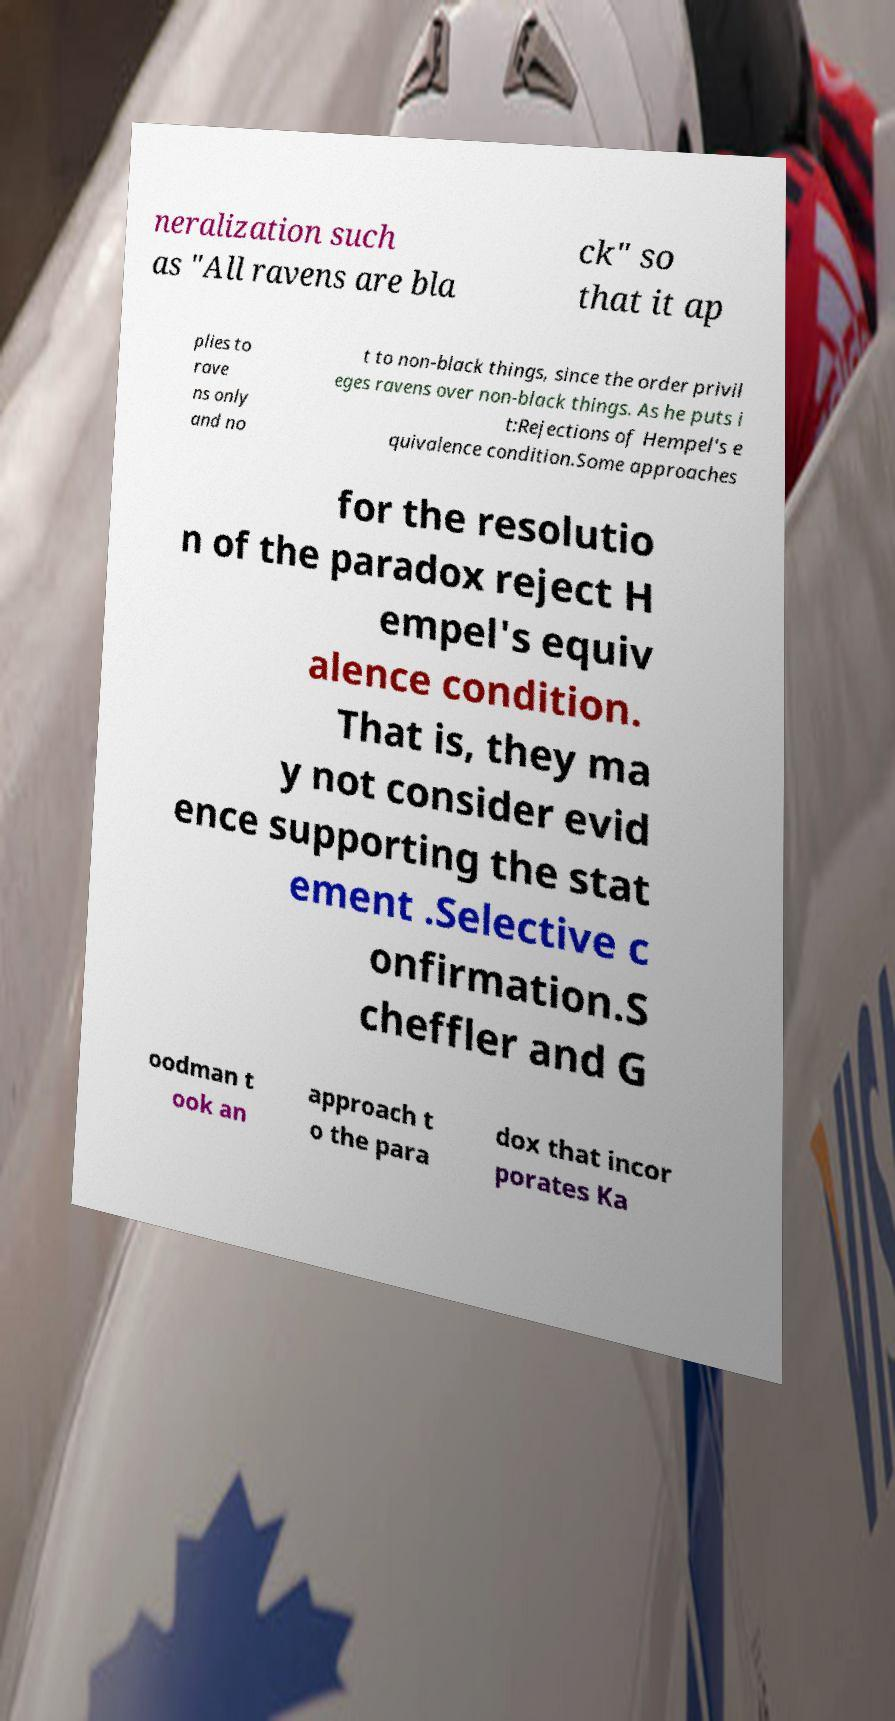Could you assist in decoding the text presented in this image and type it out clearly? neralization such as "All ravens are bla ck" so that it ap plies to rave ns only and no t to non-black things, since the order privil eges ravens over non-black things. As he puts i t:Rejections of Hempel's e quivalence condition.Some approaches for the resolutio n of the paradox reject H empel's equiv alence condition. That is, they ma y not consider evid ence supporting the stat ement .Selective c onfirmation.S cheffler and G oodman t ook an approach t o the para dox that incor porates Ka 